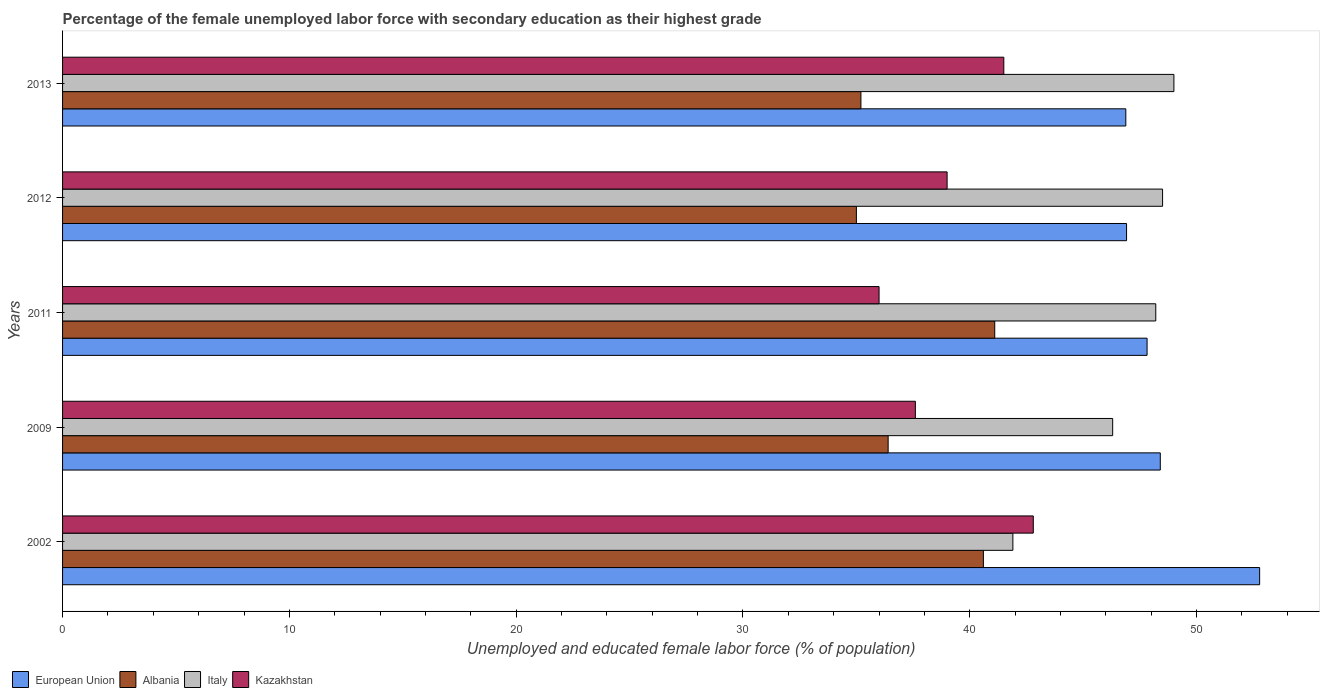Are the number of bars per tick equal to the number of legend labels?
Keep it short and to the point. Yes. Are the number of bars on each tick of the Y-axis equal?
Offer a very short reply. Yes. How many bars are there on the 3rd tick from the top?
Your response must be concise. 4. How many bars are there on the 5th tick from the bottom?
Your answer should be compact. 4. Across all years, what is the maximum percentage of the unemployed female labor force with secondary education in Kazakhstan?
Keep it short and to the point. 42.8. Across all years, what is the minimum percentage of the unemployed female labor force with secondary education in Albania?
Make the answer very short. 35. In which year was the percentage of the unemployed female labor force with secondary education in Italy maximum?
Make the answer very short. 2013. In which year was the percentage of the unemployed female labor force with secondary education in Kazakhstan minimum?
Give a very brief answer. 2011. What is the total percentage of the unemployed female labor force with secondary education in Italy in the graph?
Give a very brief answer. 233.9. What is the difference between the percentage of the unemployed female labor force with secondary education in Italy in 2002 and that in 2011?
Your answer should be very brief. -6.3. What is the difference between the percentage of the unemployed female labor force with secondary education in Kazakhstan in 2002 and the percentage of the unemployed female labor force with secondary education in European Union in 2012?
Provide a short and direct response. -4.11. What is the average percentage of the unemployed female labor force with secondary education in Italy per year?
Your answer should be very brief. 46.78. In the year 2011, what is the difference between the percentage of the unemployed female labor force with secondary education in Kazakhstan and percentage of the unemployed female labor force with secondary education in European Union?
Make the answer very short. -11.82. What is the ratio of the percentage of the unemployed female labor force with secondary education in Kazakhstan in 2002 to that in 2012?
Your response must be concise. 1.1. What is the difference between the highest and the lowest percentage of the unemployed female labor force with secondary education in European Union?
Provide a succinct answer. 5.9. In how many years, is the percentage of the unemployed female labor force with secondary education in Kazakhstan greater than the average percentage of the unemployed female labor force with secondary education in Kazakhstan taken over all years?
Provide a succinct answer. 2. Is the sum of the percentage of the unemployed female labor force with secondary education in European Union in 2011 and 2013 greater than the maximum percentage of the unemployed female labor force with secondary education in Kazakhstan across all years?
Your response must be concise. Yes. What does the 1st bar from the top in 2013 represents?
Offer a terse response. Kazakhstan. Are all the bars in the graph horizontal?
Provide a short and direct response. Yes. How many years are there in the graph?
Your response must be concise. 5. What is the difference between two consecutive major ticks on the X-axis?
Keep it short and to the point. 10. Are the values on the major ticks of X-axis written in scientific E-notation?
Your answer should be compact. No. Does the graph contain any zero values?
Make the answer very short. No. Does the graph contain grids?
Ensure brevity in your answer.  No. How many legend labels are there?
Make the answer very short. 4. What is the title of the graph?
Offer a terse response. Percentage of the female unemployed labor force with secondary education as their highest grade. What is the label or title of the X-axis?
Give a very brief answer. Unemployed and educated female labor force (% of population). What is the Unemployed and educated female labor force (% of population) of European Union in 2002?
Ensure brevity in your answer.  52.78. What is the Unemployed and educated female labor force (% of population) of Albania in 2002?
Provide a succinct answer. 40.6. What is the Unemployed and educated female labor force (% of population) of Italy in 2002?
Your response must be concise. 41.9. What is the Unemployed and educated female labor force (% of population) in Kazakhstan in 2002?
Ensure brevity in your answer.  42.8. What is the Unemployed and educated female labor force (% of population) in European Union in 2009?
Your answer should be compact. 48.4. What is the Unemployed and educated female labor force (% of population) of Albania in 2009?
Your answer should be compact. 36.4. What is the Unemployed and educated female labor force (% of population) of Italy in 2009?
Your answer should be compact. 46.3. What is the Unemployed and educated female labor force (% of population) of Kazakhstan in 2009?
Your answer should be compact. 37.6. What is the Unemployed and educated female labor force (% of population) of European Union in 2011?
Make the answer very short. 47.82. What is the Unemployed and educated female labor force (% of population) of Albania in 2011?
Ensure brevity in your answer.  41.1. What is the Unemployed and educated female labor force (% of population) of Italy in 2011?
Provide a succinct answer. 48.2. What is the Unemployed and educated female labor force (% of population) of European Union in 2012?
Give a very brief answer. 46.91. What is the Unemployed and educated female labor force (% of population) of Italy in 2012?
Offer a very short reply. 48.5. What is the Unemployed and educated female labor force (% of population) of European Union in 2013?
Your answer should be compact. 46.88. What is the Unemployed and educated female labor force (% of population) of Albania in 2013?
Your answer should be compact. 35.2. What is the Unemployed and educated female labor force (% of population) in Italy in 2013?
Provide a short and direct response. 49. What is the Unemployed and educated female labor force (% of population) of Kazakhstan in 2013?
Give a very brief answer. 41.5. Across all years, what is the maximum Unemployed and educated female labor force (% of population) in European Union?
Ensure brevity in your answer.  52.78. Across all years, what is the maximum Unemployed and educated female labor force (% of population) in Albania?
Make the answer very short. 41.1. Across all years, what is the maximum Unemployed and educated female labor force (% of population) of Italy?
Your answer should be compact. 49. Across all years, what is the maximum Unemployed and educated female labor force (% of population) in Kazakhstan?
Offer a very short reply. 42.8. Across all years, what is the minimum Unemployed and educated female labor force (% of population) of European Union?
Offer a very short reply. 46.88. Across all years, what is the minimum Unemployed and educated female labor force (% of population) of Albania?
Your response must be concise. 35. Across all years, what is the minimum Unemployed and educated female labor force (% of population) in Italy?
Your response must be concise. 41.9. Across all years, what is the minimum Unemployed and educated female labor force (% of population) in Kazakhstan?
Give a very brief answer. 36. What is the total Unemployed and educated female labor force (% of population) of European Union in the graph?
Ensure brevity in your answer.  242.79. What is the total Unemployed and educated female labor force (% of population) of Albania in the graph?
Make the answer very short. 188.3. What is the total Unemployed and educated female labor force (% of population) in Italy in the graph?
Your response must be concise. 233.9. What is the total Unemployed and educated female labor force (% of population) in Kazakhstan in the graph?
Provide a succinct answer. 196.9. What is the difference between the Unemployed and educated female labor force (% of population) of European Union in 2002 and that in 2009?
Provide a short and direct response. 4.38. What is the difference between the Unemployed and educated female labor force (% of population) of Albania in 2002 and that in 2009?
Keep it short and to the point. 4.2. What is the difference between the Unemployed and educated female labor force (% of population) of Italy in 2002 and that in 2009?
Make the answer very short. -4.4. What is the difference between the Unemployed and educated female labor force (% of population) of Kazakhstan in 2002 and that in 2009?
Make the answer very short. 5.2. What is the difference between the Unemployed and educated female labor force (% of population) in European Union in 2002 and that in 2011?
Provide a short and direct response. 4.96. What is the difference between the Unemployed and educated female labor force (% of population) in European Union in 2002 and that in 2012?
Give a very brief answer. 5.87. What is the difference between the Unemployed and educated female labor force (% of population) of Albania in 2002 and that in 2012?
Keep it short and to the point. 5.6. What is the difference between the Unemployed and educated female labor force (% of population) in Italy in 2002 and that in 2012?
Your answer should be compact. -6.6. What is the difference between the Unemployed and educated female labor force (% of population) in European Union in 2002 and that in 2013?
Keep it short and to the point. 5.9. What is the difference between the Unemployed and educated female labor force (% of population) in European Union in 2009 and that in 2011?
Provide a succinct answer. 0.58. What is the difference between the Unemployed and educated female labor force (% of population) of Italy in 2009 and that in 2011?
Ensure brevity in your answer.  -1.9. What is the difference between the Unemployed and educated female labor force (% of population) of Kazakhstan in 2009 and that in 2011?
Offer a terse response. 1.6. What is the difference between the Unemployed and educated female labor force (% of population) in European Union in 2009 and that in 2012?
Provide a succinct answer. 1.49. What is the difference between the Unemployed and educated female labor force (% of population) of Kazakhstan in 2009 and that in 2012?
Make the answer very short. -1.4. What is the difference between the Unemployed and educated female labor force (% of population) in European Union in 2009 and that in 2013?
Provide a short and direct response. 1.52. What is the difference between the Unemployed and educated female labor force (% of population) in European Union in 2011 and that in 2012?
Provide a succinct answer. 0.9. What is the difference between the Unemployed and educated female labor force (% of population) in Albania in 2011 and that in 2012?
Ensure brevity in your answer.  6.1. What is the difference between the Unemployed and educated female labor force (% of population) of European Union in 2011 and that in 2013?
Your answer should be compact. 0.94. What is the difference between the Unemployed and educated female labor force (% of population) in Albania in 2011 and that in 2013?
Ensure brevity in your answer.  5.9. What is the difference between the Unemployed and educated female labor force (% of population) in European Union in 2012 and that in 2013?
Your answer should be compact. 0.03. What is the difference between the Unemployed and educated female labor force (% of population) of Italy in 2012 and that in 2013?
Provide a succinct answer. -0.5. What is the difference between the Unemployed and educated female labor force (% of population) of European Union in 2002 and the Unemployed and educated female labor force (% of population) of Albania in 2009?
Ensure brevity in your answer.  16.38. What is the difference between the Unemployed and educated female labor force (% of population) of European Union in 2002 and the Unemployed and educated female labor force (% of population) of Italy in 2009?
Provide a succinct answer. 6.48. What is the difference between the Unemployed and educated female labor force (% of population) in European Union in 2002 and the Unemployed and educated female labor force (% of population) in Kazakhstan in 2009?
Your response must be concise. 15.18. What is the difference between the Unemployed and educated female labor force (% of population) in Albania in 2002 and the Unemployed and educated female labor force (% of population) in Italy in 2009?
Offer a terse response. -5.7. What is the difference between the Unemployed and educated female labor force (% of population) of Albania in 2002 and the Unemployed and educated female labor force (% of population) of Kazakhstan in 2009?
Provide a succinct answer. 3. What is the difference between the Unemployed and educated female labor force (% of population) in Italy in 2002 and the Unemployed and educated female labor force (% of population) in Kazakhstan in 2009?
Your answer should be very brief. 4.3. What is the difference between the Unemployed and educated female labor force (% of population) in European Union in 2002 and the Unemployed and educated female labor force (% of population) in Albania in 2011?
Your answer should be compact. 11.68. What is the difference between the Unemployed and educated female labor force (% of population) of European Union in 2002 and the Unemployed and educated female labor force (% of population) of Italy in 2011?
Offer a very short reply. 4.58. What is the difference between the Unemployed and educated female labor force (% of population) of European Union in 2002 and the Unemployed and educated female labor force (% of population) of Kazakhstan in 2011?
Your answer should be very brief. 16.78. What is the difference between the Unemployed and educated female labor force (% of population) in Albania in 2002 and the Unemployed and educated female labor force (% of population) in Kazakhstan in 2011?
Offer a terse response. 4.6. What is the difference between the Unemployed and educated female labor force (% of population) of Italy in 2002 and the Unemployed and educated female labor force (% of population) of Kazakhstan in 2011?
Make the answer very short. 5.9. What is the difference between the Unemployed and educated female labor force (% of population) of European Union in 2002 and the Unemployed and educated female labor force (% of population) of Albania in 2012?
Keep it short and to the point. 17.78. What is the difference between the Unemployed and educated female labor force (% of population) in European Union in 2002 and the Unemployed and educated female labor force (% of population) in Italy in 2012?
Offer a very short reply. 4.28. What is the difference between the Unemployed and educated female labor force (% of population) of European Union in 2002 and the Unemployed and educated female labor force (% of population) of Kazakhstan in 2012?
Offer a very short reply. 13.78. What is the difference between the Unemployed and educated female labor force (% of population) of Albania in 2002 and the Unemployed and educated female labor force (% of population) of Italy in 2012?
Your answer should be very brief. -7.9. What is the difference between the Unemployed and educated female labor force (% of population) of Italy in 2002 and the Unemployed and educated female labor force (% of population) of Kazakhstan in 2012?
Make the answer very short. 2.9. What is the difference between the Unemployed and educated female labor force (% of population) of European Union in 2002 and the Unemployed and educated female labor force (% of population) of Albania in 2013?
Provide a succinct answer. 17.58. What is the difference between the Unemployed and educated female labor force (% of population) in European Union in 2002 and the Unemployed and educated female labor force (% of population) in Italy in 2013?
Your answer should be compact. 3.78. What is the difference between the Unemployed and educated female labor force (% of population) in European Union in 2002 and the Unemployed and educated female labor force (% of population) in Kazakhstan in 2013?
Provide a short and direct response. 11.28. What is the difference between the Unemployed and educated female labor force (% of population) of European Union in 2009 and the Unemployed and educated female labor force (% of population) of Albania in 2011?
Give a very brief answer. 7.3. What is the difference between the Unemployed and educated female labor force (% of population) of European Union in 2009 and the Unemployed and educated female labor force (% of population) of Italy in 2011?
Offer a very short reply. 0.2. What is the difference between the Unemployed and educated female labor force (% of population) in European Union in 2009 and the Unemployed and educated female labor force (% of population) in Kazakhstan in 2011?
Ensure brevity in your answer.  12.4. What is the difference between the Unemployed and educated female labor force (% of population) of Albania in 2009 and the Unemployed and educated female labor force (% of population) of Italy in 2011?
Your answer should be very brief. -11.8. What is the difference between the Unemployed and educated female labor force (% of population) in Albania in 2009 and the Unemployed and educated female labor force (% of population) in Kazakhstan in 2011?
Offer a terse response. 0.4. What is the difference between the Unemployed and educated female labor force (% of population) in European Union in 2009 and the Unemployed and educated female labor force (% of population) in Albania in 2012?
Provide a short and direct response. 13.4. What is the difference between the Unemployed and educated female labor force (% of population) of European Union in 2009 and the Unemployed and educated female labor force (% of population) of Italy in 2012?
Provide a succinct answer. -0.1. What is the difference between the Unemployed and educated female labor force (% of population) of European Union in 2009 and the Unemployed and educated female labor force (% of population) of Kazakhstan in 2012?
Your response must be concise. 9.4. What is the difference between the Unemployed and educated female labor force (% of population) of European Union in 2009 and the Unemployed and educated female labor force (% of population) of Albania in 2013?
Provide a succinct answer. 13.2. What is the difference between the Unemployed and educated female labor force (% of population) of European Union in 2009 and the Unemployed and educated female labor force (% of population) of Italy in 2013?
Keep it short and to the point. -0.6. What is the difference between the Unemployed and educated female labor force (% of population) in European Union in 2009 and the Unemployed and educated female labor force (% of population) in Kazakhstan in 2013?
Make the answer very short. 6.9. What is the difference between the Unemployed and educated female labor force (% of population) of Albania in 2009 and the Unemployed and educated female labor force (% of population) of Italy in 2013?
Provide a succinct answer. -12.6. What is the difference between the Unemployed and educated female labor force (% of population) of Italy in 2009 and the Unemployed and educated female labor force (% of population) of Kazakhstan in 2013?
Your answer should be very brief. 4.8. What is the difference between the Unemployed and educated female labor force (% of population) of European Union in 2011 and the Unemployed and educated female labor force (% of population) of Albania in 2012?
Your answer should be compact. 12.82. What is the difference between the Unemployed and educated female labor force (% of population) of European Union in 2011 and the Unemployed and educated female labor force (% of population) of Italy in 2012?
Give a very brief answer. -0.68. What is the difference between the Unemployed and educated female labor force (% of population) in European Union in 2011 and the Unemployed and educated female labor force (% of population) in Kazakhstan in 2012?
Keep it short and to the point. 8.82. What is the difference between the Unemployed and educated female labor force (% of population) in Italy in 2011 and the Unemployed and educated female labor force (% of population) in Kazakhstan in 2012?
Your response must be concise. 9.2. What is the difference between the Unemployed and educated female labor force (% of population) of European Union in 2011 and the Unemployed and educated female labor force (% of population) of Albania in 2013?
Your response must be concise. 12.62. What is the difference between the Unemployed and educated female labor force (% of population) in European Union in 2011 and the Unemployed and educated female labor force (% of population) in Italy in 2013?
Give a very brief answer. -1.18. What is the difference between the Unemployed and educated female labor force (% of population) in European Union in 2011 and the Unemployed and educated female labor force (% of population) in Kazakhstan in 2013?
Make the answer very short. 6.32. What is the difference between the Unemployed and educated female labor force (% of population) in Albania in 2011 and the Unemployed and educated female labor force (% of population) in Italy in 2013?
Provide a succinct answer. -7.9. What is the difference between the Unemployed and educated female labor force (% of population) of Italy in 2011 and the Unemployed and educated female labor force (% of population) of Kazakhstan in 2013?
Provide a succinct answer. 6.7. What is the difference between the Unemployed and educated female labor force (% of population) in European Union in 2012 and the Unemployed and educated female labor force (% of population) in Albania in 2013?
Keep it short and to the point. 11.71. What is the difference between the Unemployed and educated female labor force (% of population) in European Union in 2012 and the Unemployed and educated female labor force (% of population) in Italy in 2013?
Your answer should be very brief. -2.09. What is the difference between the Unemployed and educated female labor force (% of population) in European Union in 2012 and the Unemployed and educated female labor force (% of population) in Kazakhstan in 2013?
Your answer should be compact. 5.41. What is the difference between the Unemployed and educated female labor force (% of population) in Albania in 2012 and the Unemployed and educated female labor force (% of population) in Italy in 2013?
Your response must be concise. -14. What is the difference between the Unemployed and educated female labor force (% of population) in Italy in 2012 and the Unemployed and educated female labor force (% of population) in Kazakhstan in 2013?
Your answer should be compact. 7. What is the average Unemployed and educated female labor force (% of population) in European Union per year?
Make the answer very short. 48.56. What is the average Unemployed and educated female labor force (% of population) in Albania per year?
Ensure brevity in your answer.  37.66. What is the average Unemployed and educated female labor force (% of population) in Italy per year?
Offer a very short reply. 46.78. What is the average Unemployed and educated female labor force (% of population) of Kazakhstan per year?
Your answer should be compact. 39.38. In the year 2002, what is the difference between the Unemployed and educated female labor force (% of population) of European Union and Unemployed and educated female labor force (% of population) of Albania?
Offer a terse response. 12.18. In the year 2002, what is the difference between the Unemployed and educated female labor force (% of population) of European Union and Unemployed and educated female labor force (% of population) of Italy?
Offer a very short reply. 10.88. In the year 2002, what is the difference between the Unemployed and educated female labor force (% of population) of European Union and Unemployed and educated female labor force (% of population) of Kazakhstan?
Offer a very short reply. 9.98. In the year 2002, what is the difference between the Unemployed and educated female labor force (% of population) of Albania and Unemployed and educated female labor force (% of population) of Italy?
Provide a succinct answer. -1.3. In the year 2002, what is the difference between the Unemployed and educated female labor force (% of population) in Albania and Unemployed and educated female labor force (% of population) in Kazakhstan?
Your response must be concise. -2.2. In the year 2009, what is the difference between the Unemployed and educated female labor force (% of population) in European Union and Unemployed and educated female labor force (% of population) in Albania?
Provide a succinct answer. 12. In the year 2009, what is the difference between the Unemployed and educated female labor force (% of population) in European Union and Unemployed and educated female labor force (% of population) in Italy?
Give a very brief answer. 2.1. In the year 2009, what is the difference between the Unemployed and educated female labor force (% of population) in European Union and Unemployed and educated female labor force (% of population) in Kazakhstan?
Your answer should be compact. 10.8. In the year 2009, what is the difference between the Unemployed and educated female labor force (% of population) of Albania and Unemployed and educated female labor force (% of population) of Italy?
Your answer should be very brief. -9.9. In the year 2011, what is the difference between the Unemployed and educated female labor force (% of population) in European Union and Unemployed and educated female labor force (% of population) in Albania?
Offer a terse response. 6.72. In the year 2011, what is the difference between the Unemployed and educated female labor force (% of population) in European Union and Unemployed and educated female labor force (% of population) in Italy?
Offer a very short reply. -0.38. In the year 2011, what is the difference between the Unemployed and educated female labor force (% of population) in European Union and Unemployed and educated female labor force (% of population) in Kazakhstan?
Offer a very short reply. 11.82. In the year 2012, what is the difference between the Unemployed and educated female labor force (% of population) in European Union and Unemployed and educated female labor force (% of population) in Albania?
Provide a succinct answer. 11.91. In the year 2012, what is the difference between the Unemployed and educated female labor force (% of population) of European Union and Unemployed and educated female labor force (% of population) of Italy?
Your answer should be very brief. -1.59. In the year 2012, what is the difference between the Unemployed and educated female labor force (% of population) of European Union and Unemployed and educated female labor force (% of population) of Kazakhstan?
Ensure brevity in your answer.  7.91. In the year 2012, what is the difference between the Unemployed and educated female labor force (% of population) in Albania and Unemployed and educated female labor force (% of population) in Italy?
Provide a short and direct response. -13.5. In the year 2012, what is the difference between the Unemployed and educated female labor force (% of population) in Albania and Unemployed and educated female labor force (% of population) in Kazakhstan?
Offer a very short reply. -4. In the year 2012, what is the difference between the Unemployed and educated female labor force (% of population) in Italy and Unemployed and educated female labor force (% of population) in Kazakhstan?
Provide a succinct answer. 9.5. In the year 2013, what is the difference between the Unemployed and educated female labor force (% of population) in European Union and Unemployed and educated female labor force (% of population) in Albania?
Your answer should be compact. 11.68. In the year 2013, what is the difference between the Unemployed and educated female labor force (% of population) in European Union and Unemployed and educated female labor force (% of population) in Italy?
Your answer should be compact. -2.12. In the year 2013, what is the difference between the Unemployed and educated female labor force (% of population) of European Union and Unemployed and educated female labor force (% of population) of Kazakhstan?
Your answer should be very brief. 5.38. In the year 2013, what is the difference between the Unemployed and educated female labor force (% of population) of Albania and Unemployed and educated female labor force (% of population) of Italy?
Your answer should be compact. -13.8. In the year 2013, what is the difference between the Unemployed and educated female labor force (% of population) in Italy and Unemployed and educated female labor force (% of population) in Kazakhstan?
Your response must be concise. 7.5. What is the ratio of the Unemployed and educated female labor force (% of population) in European Union in 2002 to that in 2009?
Provide a short and direct response. 1.09. What is the ratio of the Unemployed and educated female labor force (% of population) in Albania in 2002 to that in 2009?
Offer a terse response. 1.12. What is the ratio of the Unemployed and educated female labor force (% of population) in Italy in 2002 to that in 2009?
Provide a succinct answer. 0.91. What is the ratio of the Unemployed and educated female labor force (% of population) in Kazakhstan in 2002 to that in 2009?
Provide a succinct answer. 1.14. What is the ratio of the Unemployed and educated female labor force (% of population) in European Union in 2002 to that in 2011?
Keep it short and to the point. 1.1. What is the ratio of the Unemployed and educated female labor force (% of population) of Italy in 2002 to that in 2011?
Keep it short and to the point. 0.87. What is the ratio of the Unemployed and educated female labor force (% of population) of Kazakhstan in 2002 to that in 2011?
Ensure brevity in your answer.  1.19. What is the ratio of the Unemployed and educated female labor force (% of population) in European Union in 2002 to that in 2012?
Give a very brief answer. 1.13. What is the ratio of the Unemployed and educated female labor force (% of population) of Albania in 2002 to that in 2012?
Provide a short and direct response. 1.16. What is the ratio of the Unemployed and educated female labor force (% of population) of Italy in 2002 to that in 2012?
Keep it short and to the point. 0.86. What is the ratio of the Unemployed and educated female labor force (% of population) in Kazakhstan in 2002 to that in 2012?
Your response must be concise. 1.1. What is the ratio of the Unemployed and educated female labor force (% of population) of European Union in 2002 to that in 2013?
Provide a short and direct response. 1.13. What is the ratio of the Unemployed and educated female labor force (% of population) in Albania in 2002 to that in 2013?
Offer a terse response. 1.15. What is the ratio of the Unemployed and educated female labor force (% of population) of Italy in 2002 to that in 2013?
Give a very brief answer. 0.86. What is the ratio of the Unemployed and educated female labor force (% of population) of Kazakhstan in 2002 to that in 2013?
Give a very brief answer. 1.03. What is the ratio of the Unemployed and educated female labor force (% of population) in European Union in 2009 to that in 2011?
Offer a terse response. 1.01. What is the ratio of the Unemployed and educated female labor force (% of population) in Albania in 2009 to that in 2011?
Your response must be concise. 0.89. What is the ratio of the Unemployed and educated female labor force (% of population) in Italy in 2009 to that in 2011?
Provide a short and direct response. 0.96. What is the ratio of the Unemployed and educated female labor force (% of population) of Kazakhstan in 2009 to that in 2011?
Keep it short and to the point. 1.04. What is the ratio of the Unemployed and educated female labor force (% of population) of European Union in 2009 to that in 2012?
Provide a succinct answer. 1.03. What is the ratio of the Unemployed and educated female labor force (% of population) in Italy in 2009 to that in 2012?
Give a very brief answer. 0.95. What is the ratio of the Unemployed and educated female labor force (% of population) in Kazakhstan in 2009 to that in 2012?
Offer a terse response. 0.96. What is the ratio of the Unemployed and educated female labor force (% of population) of European Union in 2009 to that in 2013?
Offer a terse response. 1.03. What is the ratio of the Unemployed and educated female labor force (% of population) of Albania in 2009 to that in 2013?
Give a very brief answer. 1.03. What is the ratio of the Unemployed and educated female labor force (% of population) in Italy in 2009 to that in 2013?
Give a very brief answer. 0.94. What is the ratio of the Unemployed and educated female labor force (% of population) in Kazakhstan in 2009 to that in 2013?
Offer a very short reply. 0.91. What is the ratio of the Unemployed and educated female labor force (% of population) in European Union in 2011 to that in 2012?
Ensure brevity in your answer.  1.02. What is the ratio of the Unemployed and educated female labor force (% of population) in Albania in 2011 to that in 2012?
Keep it short and to the point. 1.17. What is the ratio of the Unemployed and educated female labor force (% of population) in Italy in 2011 to that in 2012?
Provide a succinct answer. 0.99. What is the ratio of the Unemployed and educated female labor force (% of population) of Albania in 2011 to that in 2013?
Your answer should be very brief. 1.17. What is the ratio of the Unemployed and educated female labor force (% of population) in Italy in 2011 to that in 2013?
Make the answer very short. 0.98. What is the ratio of the Unemployed and educated female labor force (% of population) of Kazakhstan in 2011 to that in 2013?
Your response must be concise. 0.87. What is the ratio of the Unemployed and educated female labor force (% of population) of Albania in 2012 to that in 2013?
Keep it short and to the point. 0.99. What is the ratio of the Unemployed and educated female labor force (% of population) of Kazakhstan in 2012 to that in 2013?
Offer a terse response. 0.94. What is the difference between the highest and the second highest Unemployed and educated female labor force (% of population) of European Union?
Provide a short and direct response. 4.38. What is the difference between the highest and the second highest Unemployed and educated female labor force (% of population) of Italy?
Keep it short and to the point. 0.5. What is the difference between the highest and the lowest Unemployed and educated female labor force (% of population) in European Union?
Make the answer very short. 5.9. What is the difference between the highest and the lowest Unemployed and educated female labor force (% of population) of Albania?
Offer a very short reply. 6.1. What is the difference between the highest and the lowest Unemployed and educated female labor force (% of population) of Kazakhstan?
Provide a short and direct response. 6.8. 